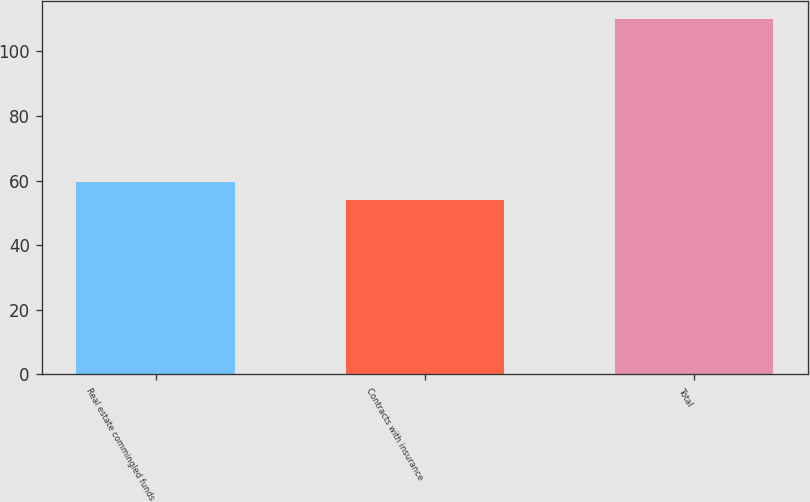<chart> <loc_0><loc_0><loc_500><loc_500><bar_chart><fcel>Real estate commingled funds<fcel>Contracts with insurance<fcel>Total<nl><fcel>59.6<fcel>54<fcel>110<nl></chart> 